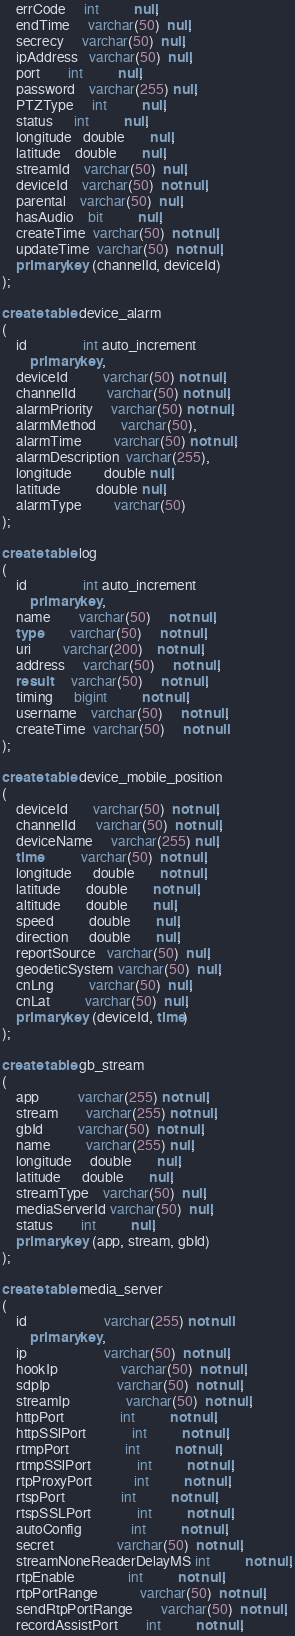<code> <loc_0><loc_0><loc_500><loc_500><_SQL_>    errCode     int          null,
    endTime     varchar(50)  null,
    secrecy     varchar(50)  null,
    ipAddress   varchar(50)  null,
    port        int          null,
    password    varchar(255) null,
    PTZType     int          null,
    status      int          null,
    longitude   double       null,
    latitude    double       null,
    streamId    varchar(50)  null,
    deviceId    varchar(50)  not null,
    parental    varchar(50)  null,
    hasAudio    bit          null,
    createTime  varchar(50)  not null,
    updateTime  varchar(50)  not null,
    primary key (channelId, deviceId)
);

create table device_alarm
(
    id                int auto_increment
        primary key,
    deviceId          varchar(50) not null,
    channelId         varchar(50) not null,
    alarmPriority     varchar(50) not null,
    alarmMethod       varchar(50),
    alarmTime         varchar(50) not null,
    alarmDescription  varchar(255),
    longitude         double null,
    latitude          double null,
    alarmType         varchar(50)
);

create table log
(
    id                int auto_increment
        primary key,
    name        varchar(50)     not null,
    type        varchar(50)     not null,
    uri         varchar(200)    not null,
    address     varchar(50)     not null,
    result      varchar(50)     not null,
    timing      bigint          not null,
    username    varchar(50)     not null,
    createTime  varchar(50)     not null
);

create table device_mobile_position
(
    deviceId       varchar(50)  not null,
    channelId      varchar(50)  not null,
    deviceName     varchar(255) null,
    time           varchar(50)  not null,
    longitude      double       not null,
    latitude       double       not null,
    altitude       double       null,
    speed          double       null,
    direction      double       null,
    reportSource   varchar(50)  null,
    geodeticSystem varchar(50)  null,
    cnLng          varchar(50)  null,
    cnLat          varchar(50)  null,
    primary key (deviceId, time)
);

create table gb_stream
(
    app           varchar(255) not null,
    stream        varchar(255) not null,
    gbId          varchar(50)  not null,
    name          varchar(255) null,
    longitude     double       null,
    latitude      double       null,
    streamType    varchar(50)  null,
    mediaServerId varchar(50)  null,
    status        int          null,
    primary key (app, stream, gbId)
);

create table media_server
(
    id                      varchar(255) not null
        primary key,
    ip                      varchar(50)  not null,
    hookIp                  varchar(50)  not null,
    sdpIp                   varchar(50)  not null,
    streamIp                varchar(50)  not null,
    httpPort                int          not null,
    httpSSlPort             int          not null,
    rtmpPort                int          not null,
    rtmpSSlPort             int          not null,
    rtpProxyPort            int          not null,
    rtspPort                int          not null,
    rtspSSLPort             int          not null,
    autoConfig              int          not null,
    secret                  varchar(50)  not null,
    streamNoneReaderDelayMS int          not null,
    rtpEnable               int          not null,
    rtpPortRange            varchar(50)  not null,
    sendRtpPortRange        varchar(50)  not null,
    recordAssistPort        int          not null,</code> 